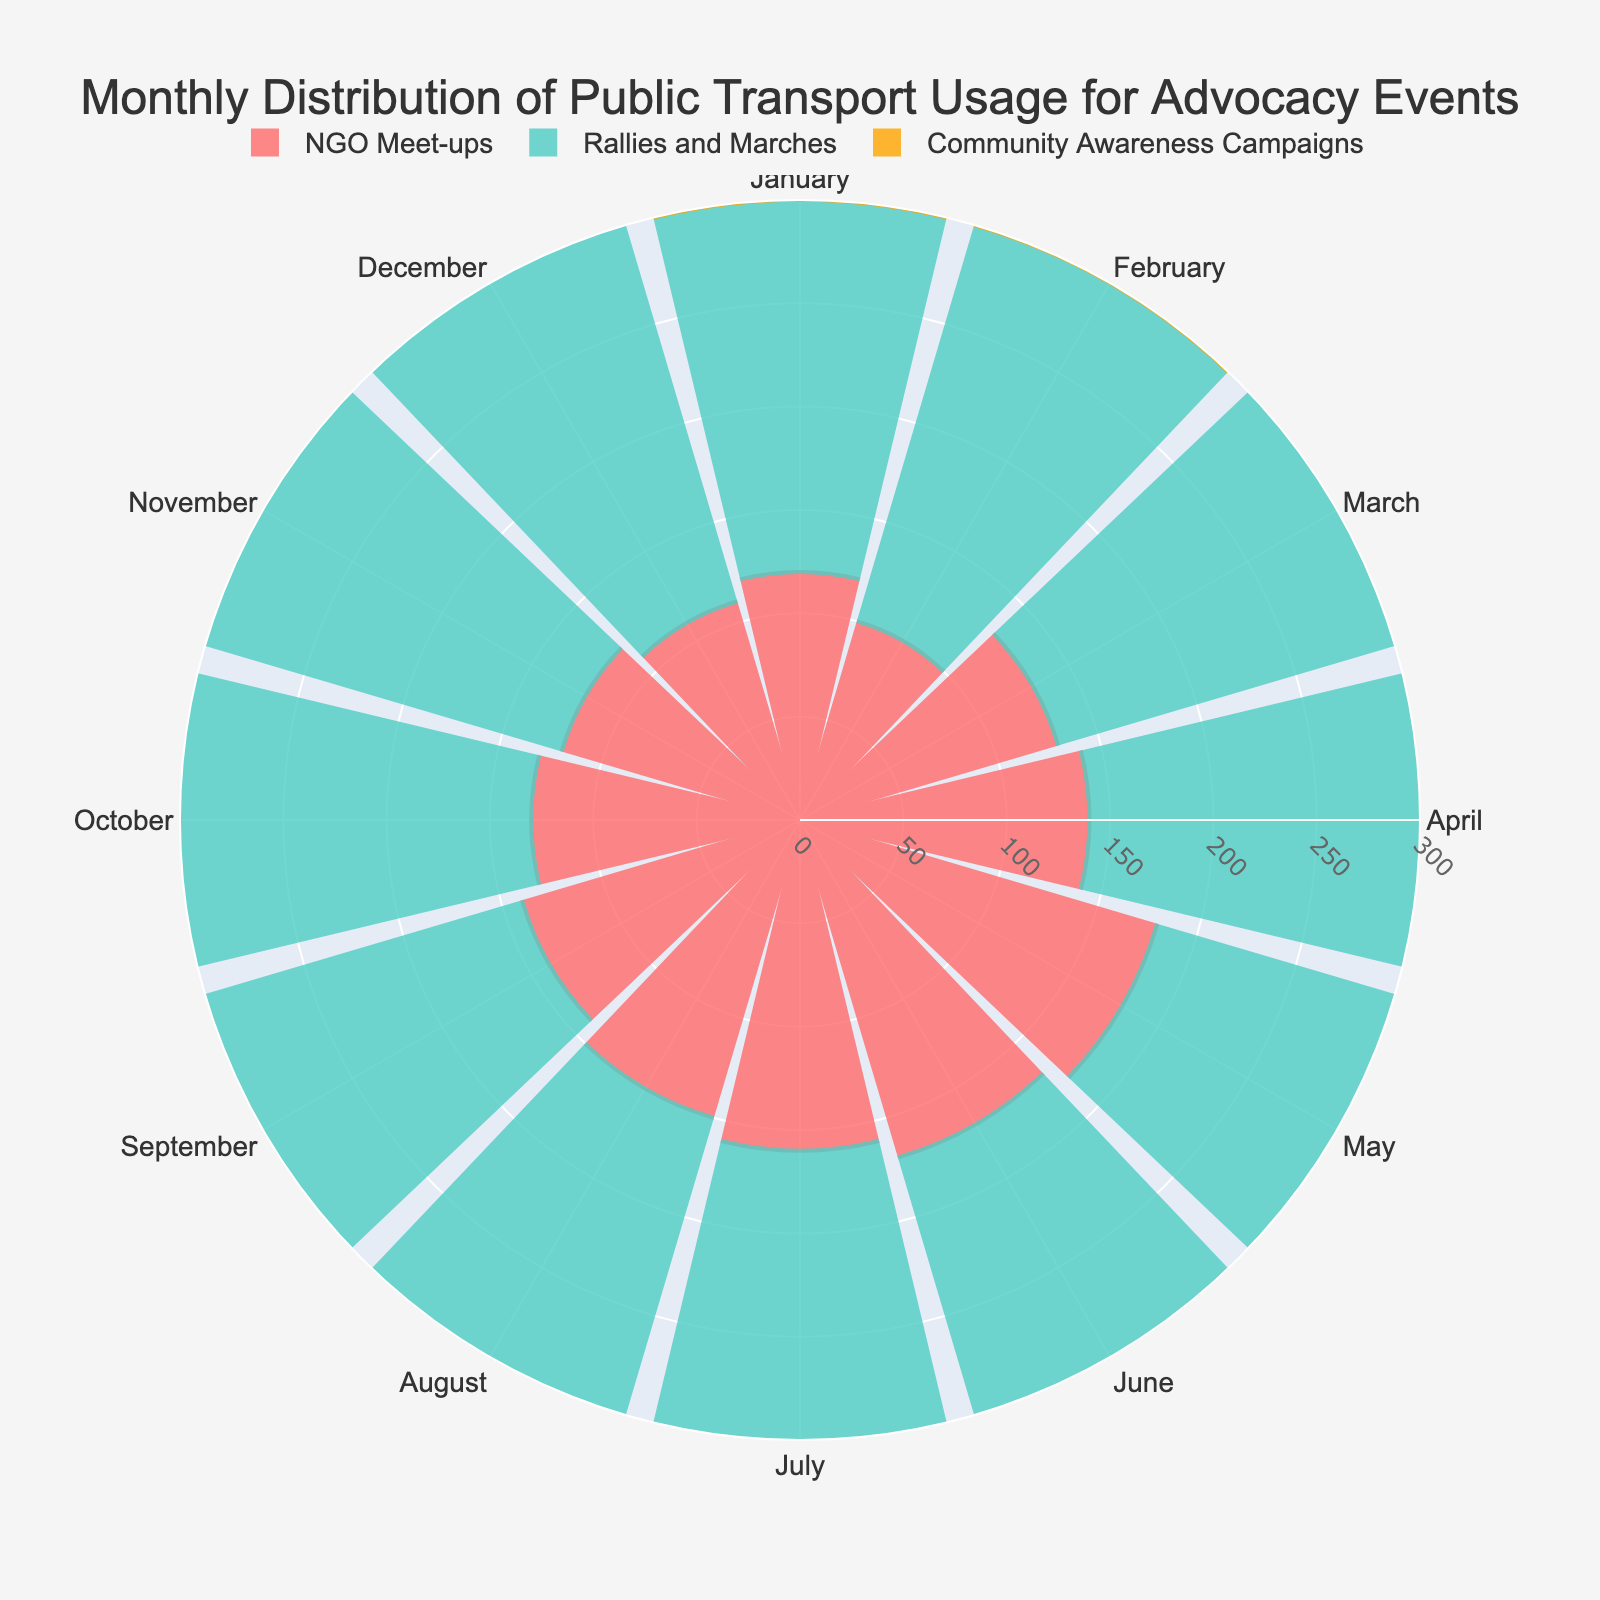What is the title of the figure? The title is usually displayed at the top of the chart, providing a summary of the visualization. In this case, it is written prominently in the center at the top part of the figure.
Answer: Monthly Distribution of Public Transport Usage for Advocacy Events Which category had the highest public transport usage in August? By observing the length of the bars for August (theta=August), the longest bar belongs to 'Rallies and Marches'.
Answer: Rallies and Marches What color represents 'Community Awareness Campaigns'? The legend at the bottom indicates each category's color. 'Community Awareness Campaigns' is marked in a distinct color.
Answer: Orange What is the transport usage for 'NGO Meet-ups' in May? Navigate to the May segment (theta=May) and observe the radial distance of the bar representing 'NGO Meet-ups', denoted in red.
Answer: 180 Which month had the minimum public transport usage for 'Rallies and Marches'? Identify the shortest bar for the 'Rallies and Marches' segment across all months.
Answer: January What is the average public transport usage for 'Community Awareness Campaigns' from January to June? Add the values for 'Community Awareness Campaigns' from January to June (140 + 130 + 120 + 150 + 160 + 140 = 840). Divide this sum by the number of months (6).
Answer: 140 How does the transport usage in December for 'NGO Meet-ups' compare to the usage in January? Compare the radial distances (heights) of the December and January bars for 'NGO Meet-ups'. January has a longer bar compared to December.
Answer: January > December What month shows an equal public transport usage for both 'Rallies and Marches' and 'Community Awareness Campaigns'? Look for months where the bars for 'Rallies and Marches' and 'Community Awareness Campaigns' are of equal length.
Answer: November What’s the total public transport usage in July across all events? Sum the values for each category in July (160 for NGO Meet-ups, 250 for Rallies and Marches, 170 for Community Awareness Campaigns). The total is 160 + 250 + 170 = 580.
Answer: 580 Which category saw the largest increase in usage from January to August? Calculate the increase for each category from January to August: 
NGO Meet-ups (150 - 120 = 30), 
Rallies and Marches (270 - 180 = 90), 
Community Awareness Campaigns (180 - 140 = 40).
Rallies and Marches show the largest increase.
Answer: Rallies and Marches 